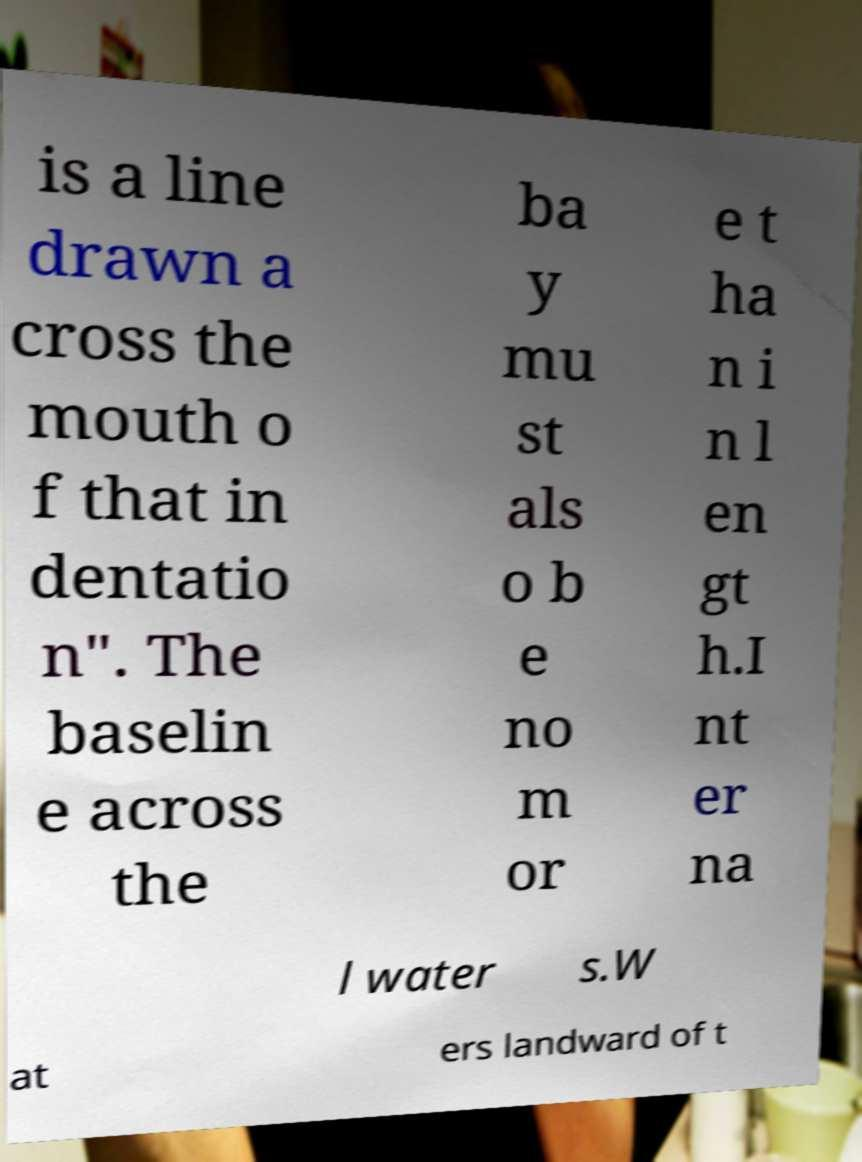I need the written content from this picture converted into text. Can you do that? is a line drawn a cross the mouth o f that in dentatio n". The baselin e across the ba y mu st als o b e no m or e t ha n i n l en gt h.I nt er na l water s.W at ers landward of t 